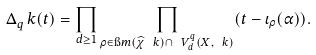Convert formula to latex. <formula><loc_0><loc_0><loc_500><loc_500>\Delta _ { q } ^ { \ } k ( t ) = \prod _ { d \geq 1 } \prod _ { \rho \in \i m ( \widehat { \chi } _ { \ } k ) \cap \ V _ { d } ^ { q } ( X , \ k ) } ( t - \iota _ { \rho } ( \alpha ) ) .</formula> 